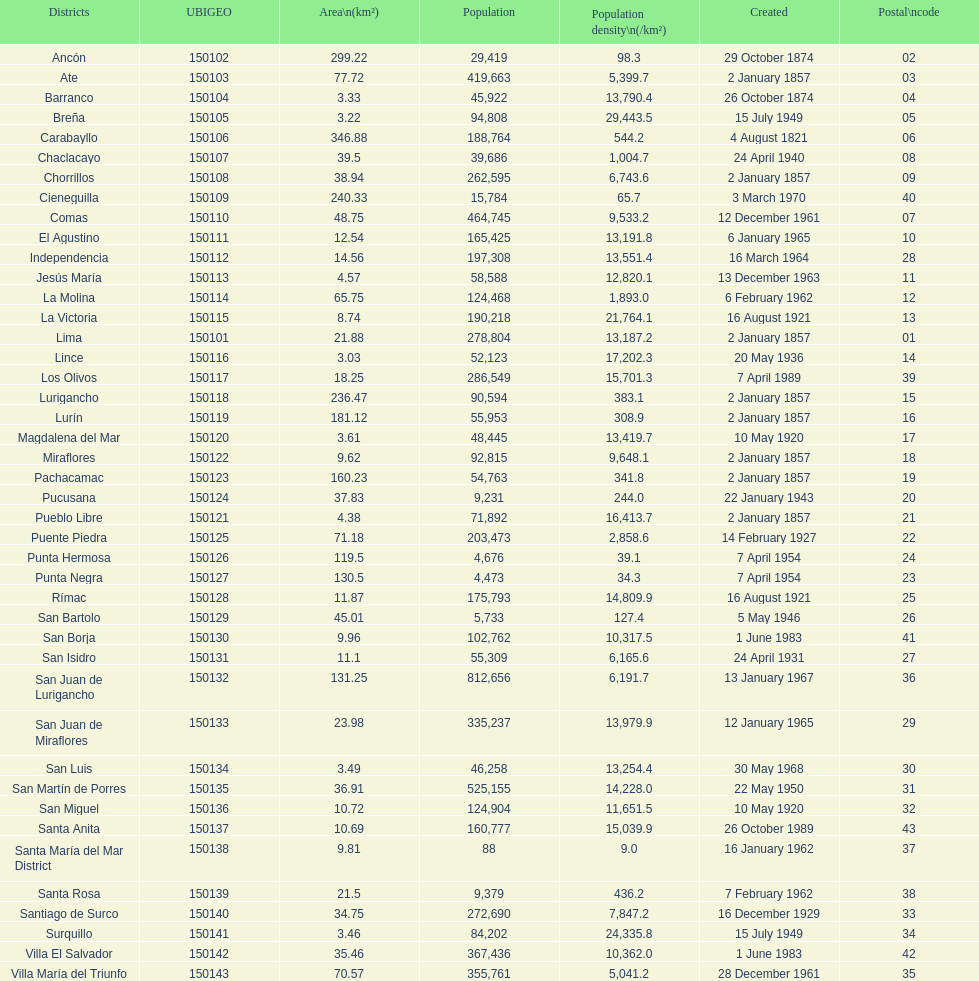What is the total number of districts of lima? 43. 